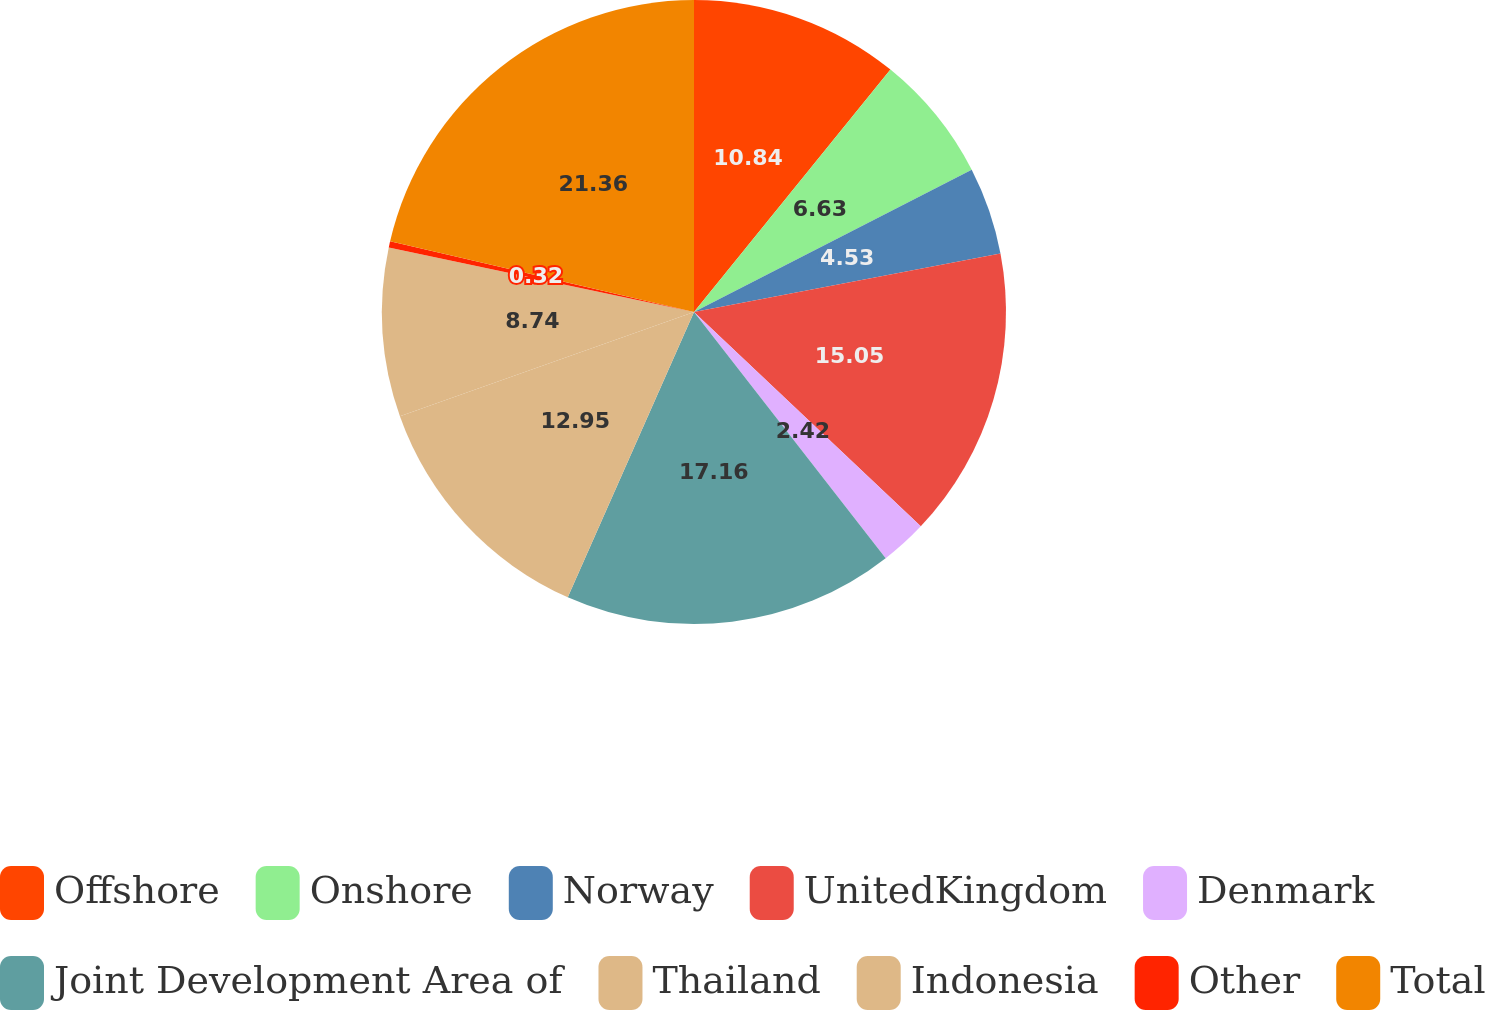Convert chart. <chart><loc_0><loc_0><loc_500><loc_500><pie_chart><fcel>Offshore<fcel>Onshore<fcel>Norway<fcel>UnitedKingdom<fcel>Denmark<fcel>Joint Development Area of<fcel>Thailand<fcel>Indonesia<fcel>Other<fcel>Total<nl><fcel>10.84%<fcel>6.63%<fcel>4.53%<fcel>15.05%<fcel>2.42%<fcel>17.16%<fcel>12.95%<fcel>8.74%<fcel>0.32%<fcel>21.36%<nl></chart> 